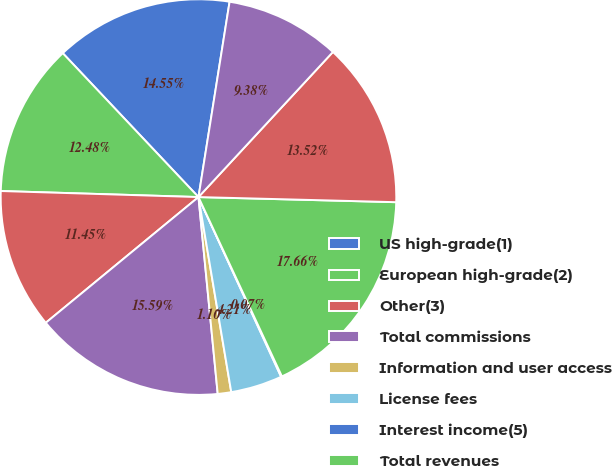Convert chart to OTSL. <chart><loc_0><loc_0><loc_500><loc_500><pie_chart><fcel>US high-grade(1)<fcel>European high-grade(2)<fcel>Other(3)<fcel>Total commissions<fcel>Information and user access<fcel>License fees<fcel>Interest income(5)<fcel>Total revenues<fcel>Employee compensation and<fcel>Depreciation and amortization<nl><fcel>14.55%<fcel>12.48%<fcel>11.45%<fcel>15.59%<fcel>1.1%<fcel>4.21%<fcel>0.07%<fcel>17.66%<fcel>13.52%<fcel>9.38%<nl></chart> 